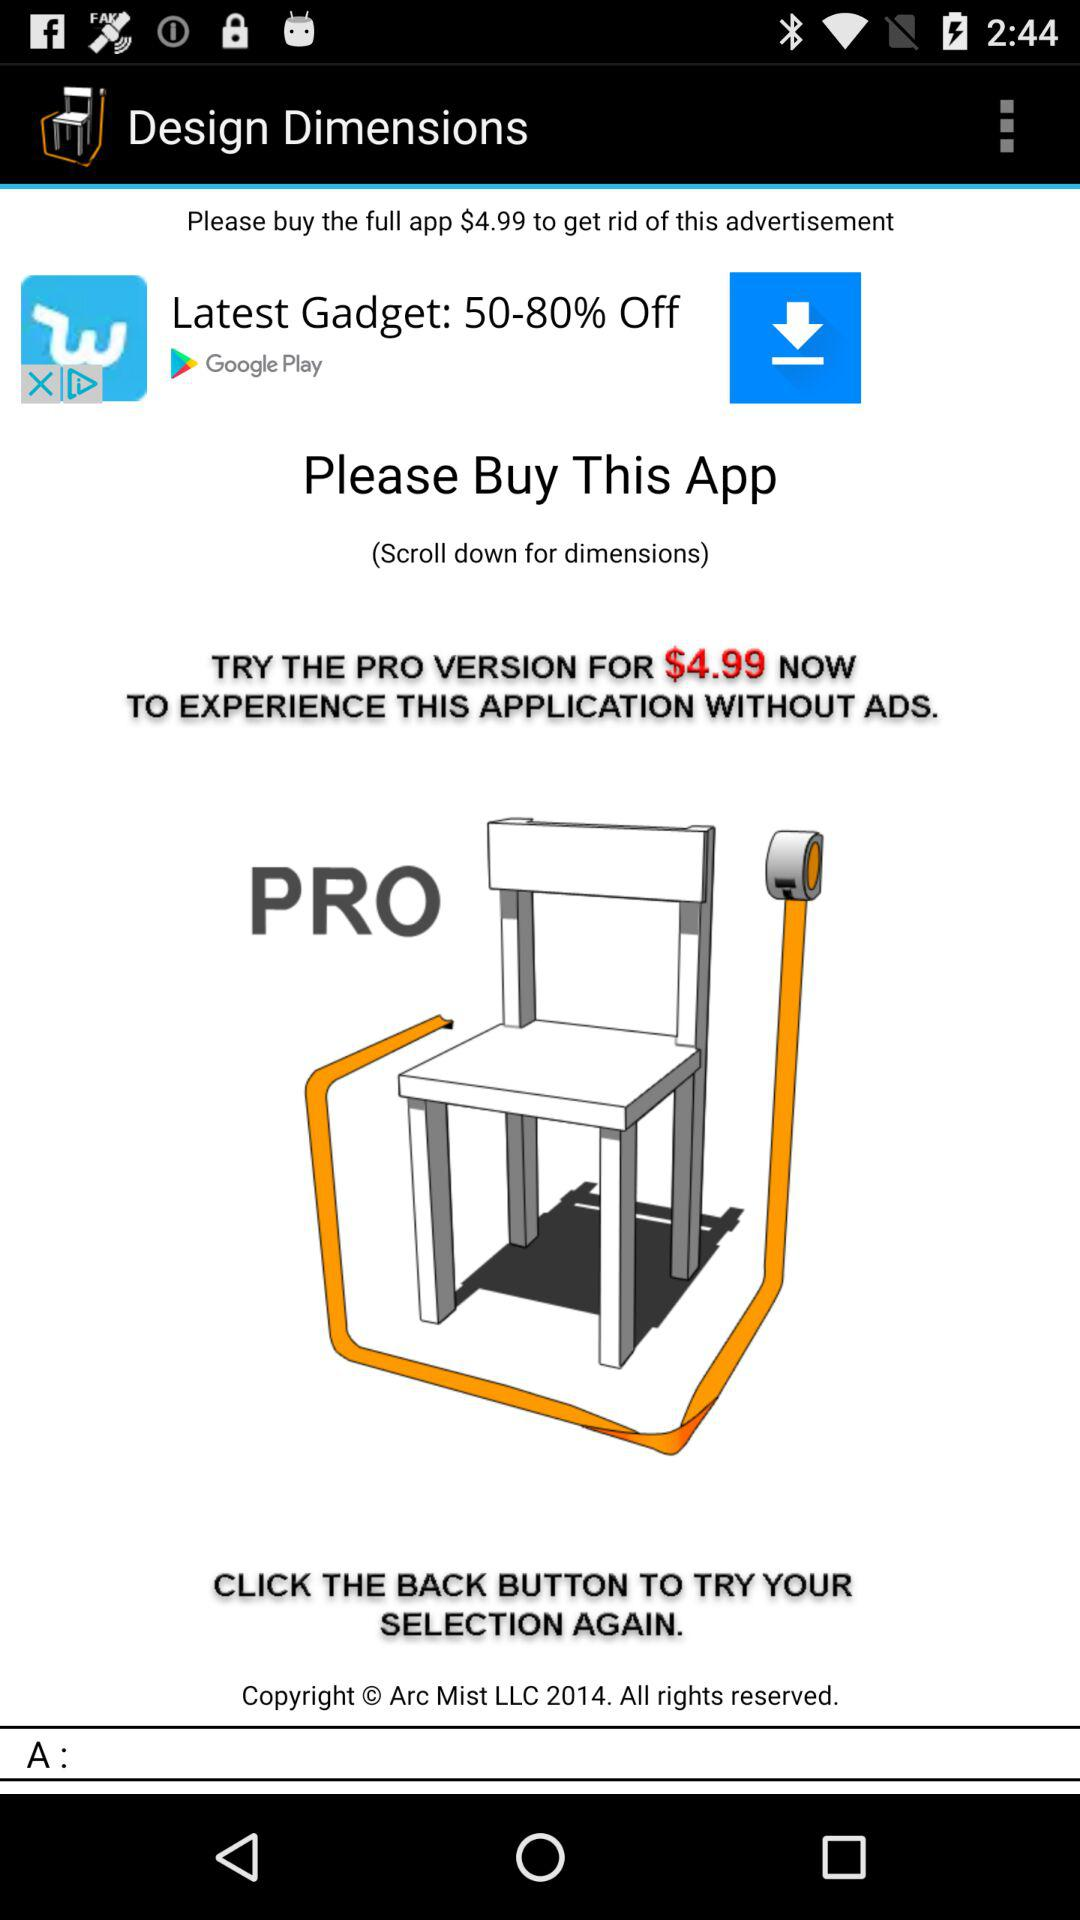How many more dollars is the price of the full app than the price of the latest gadget?
Answer the question using a single word or phrase. 4.99 